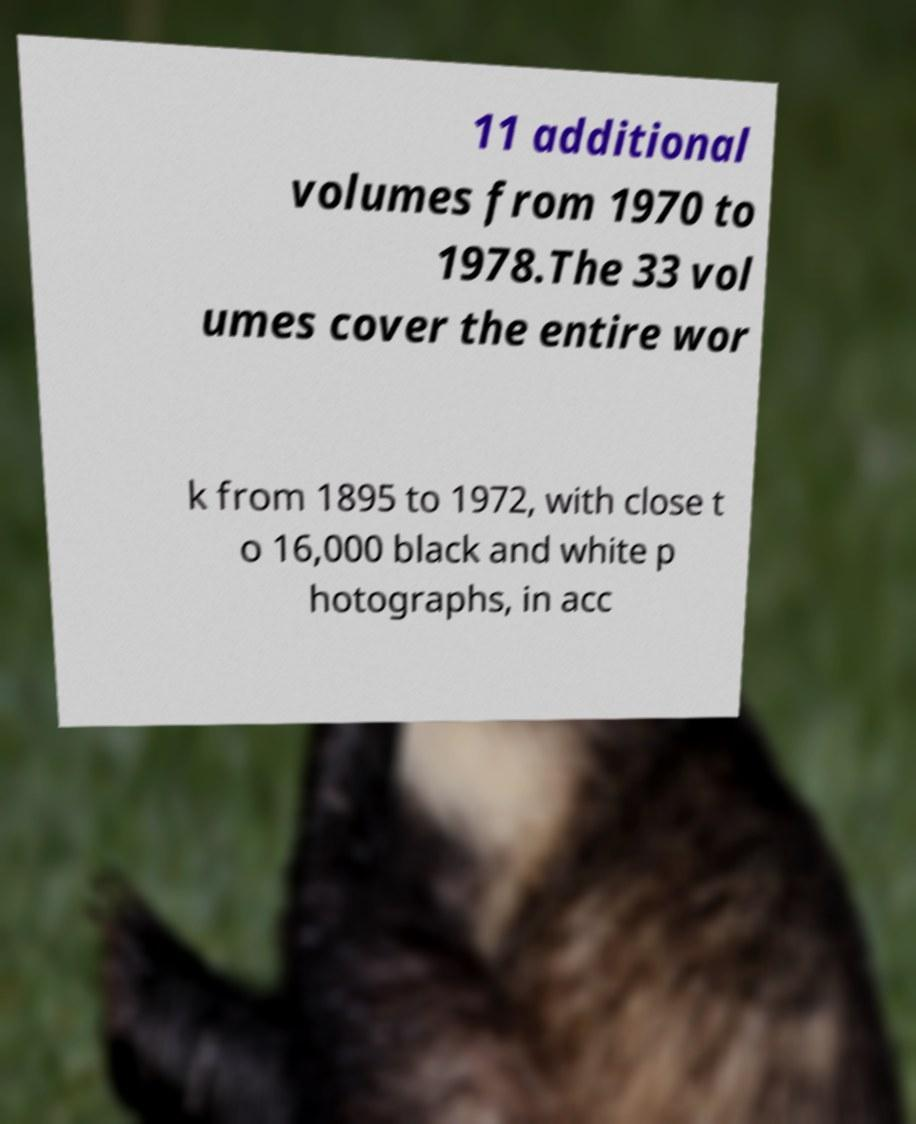There's text embedded in this image that I need extracted. Can you transcribe it verbatim? 11 additional volumes from 1970 to 1978.The 33 vol umes cover the entire wor k from 1895 to 1972, with close t o 16,000 black and white p hotographs, in acc 